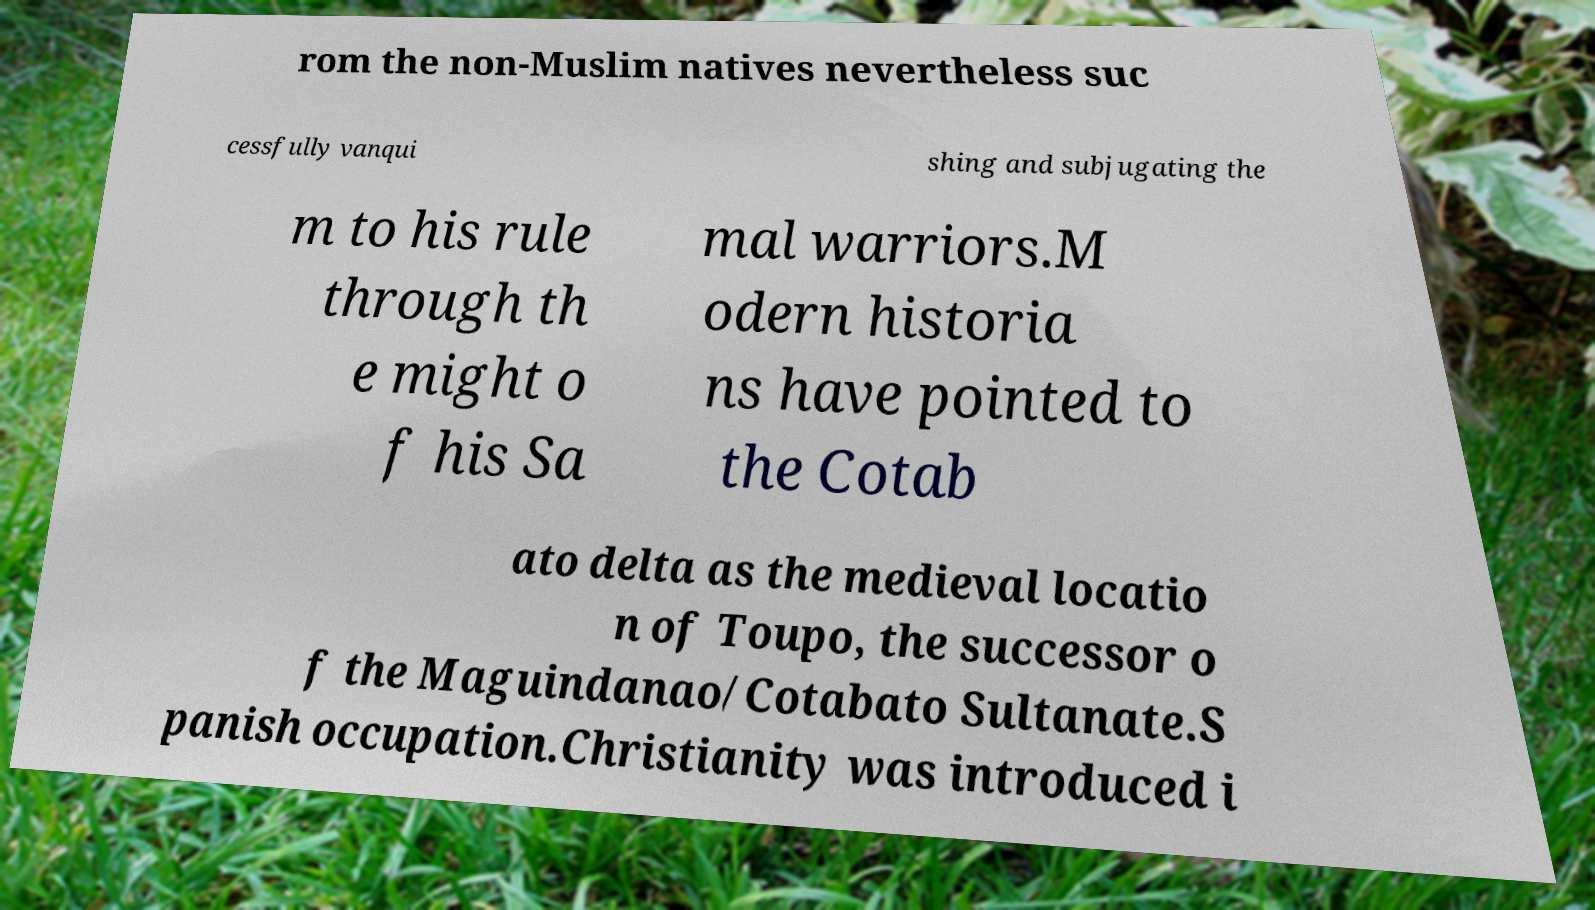Can you accurately transcribe the text from the provided image for me? rom the non-Muslim natives nevertheless suc cessfully vanqui shing and subjugating the m to his rule through th e might o f his Sa mal warriors.M odern historia ns have pointed to the Cotab ato delta as the medieval locatio n of Toupo, the successor o f the Maguindanao/Cotabato Sultanate.S panish occupation.Christianity was introduced i 